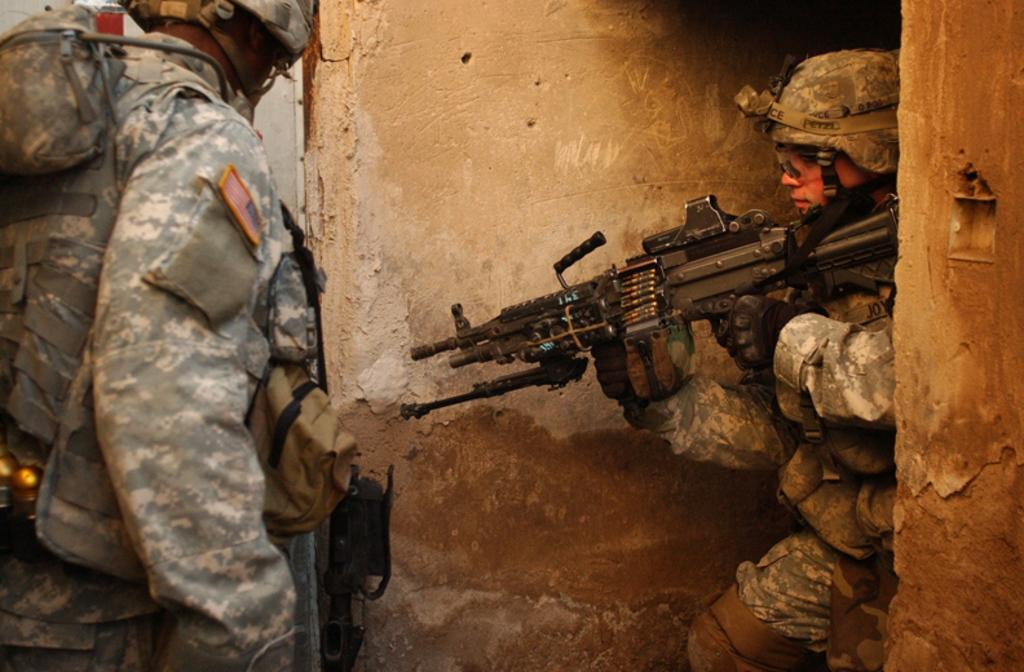How many people are in the image? There are two people in the image. What type of clothing are the people wearing? The people are wearing army clothes. What headgear are the people wearing? The people are wearing helmets. What are the people holding in their hands? The people are holding rifles in their hands. What can be seen in the background of the image? There is a wall in the image. What type of jeans is the cook wearing in the image? There is no cook or jeans present in the image. What news story is being discussed by the people in the image? There is no indication of a news story being discussed in the image. 